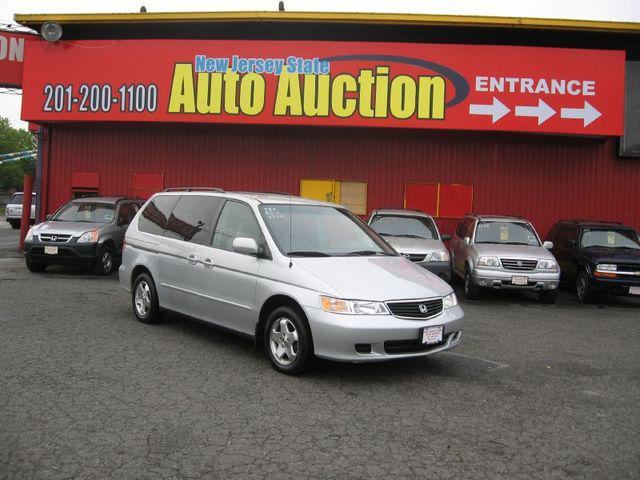Can you tell me more about the types of cars seen in the image aside from the silver van? Aside from the silver minivan in the forefront, there's a dark-colored sedan to the left and a lighter colored SUV in the background on the right. These vehicles represent a range of body styles likely chosen to appeal to different buyer preferences at an auto auction. 